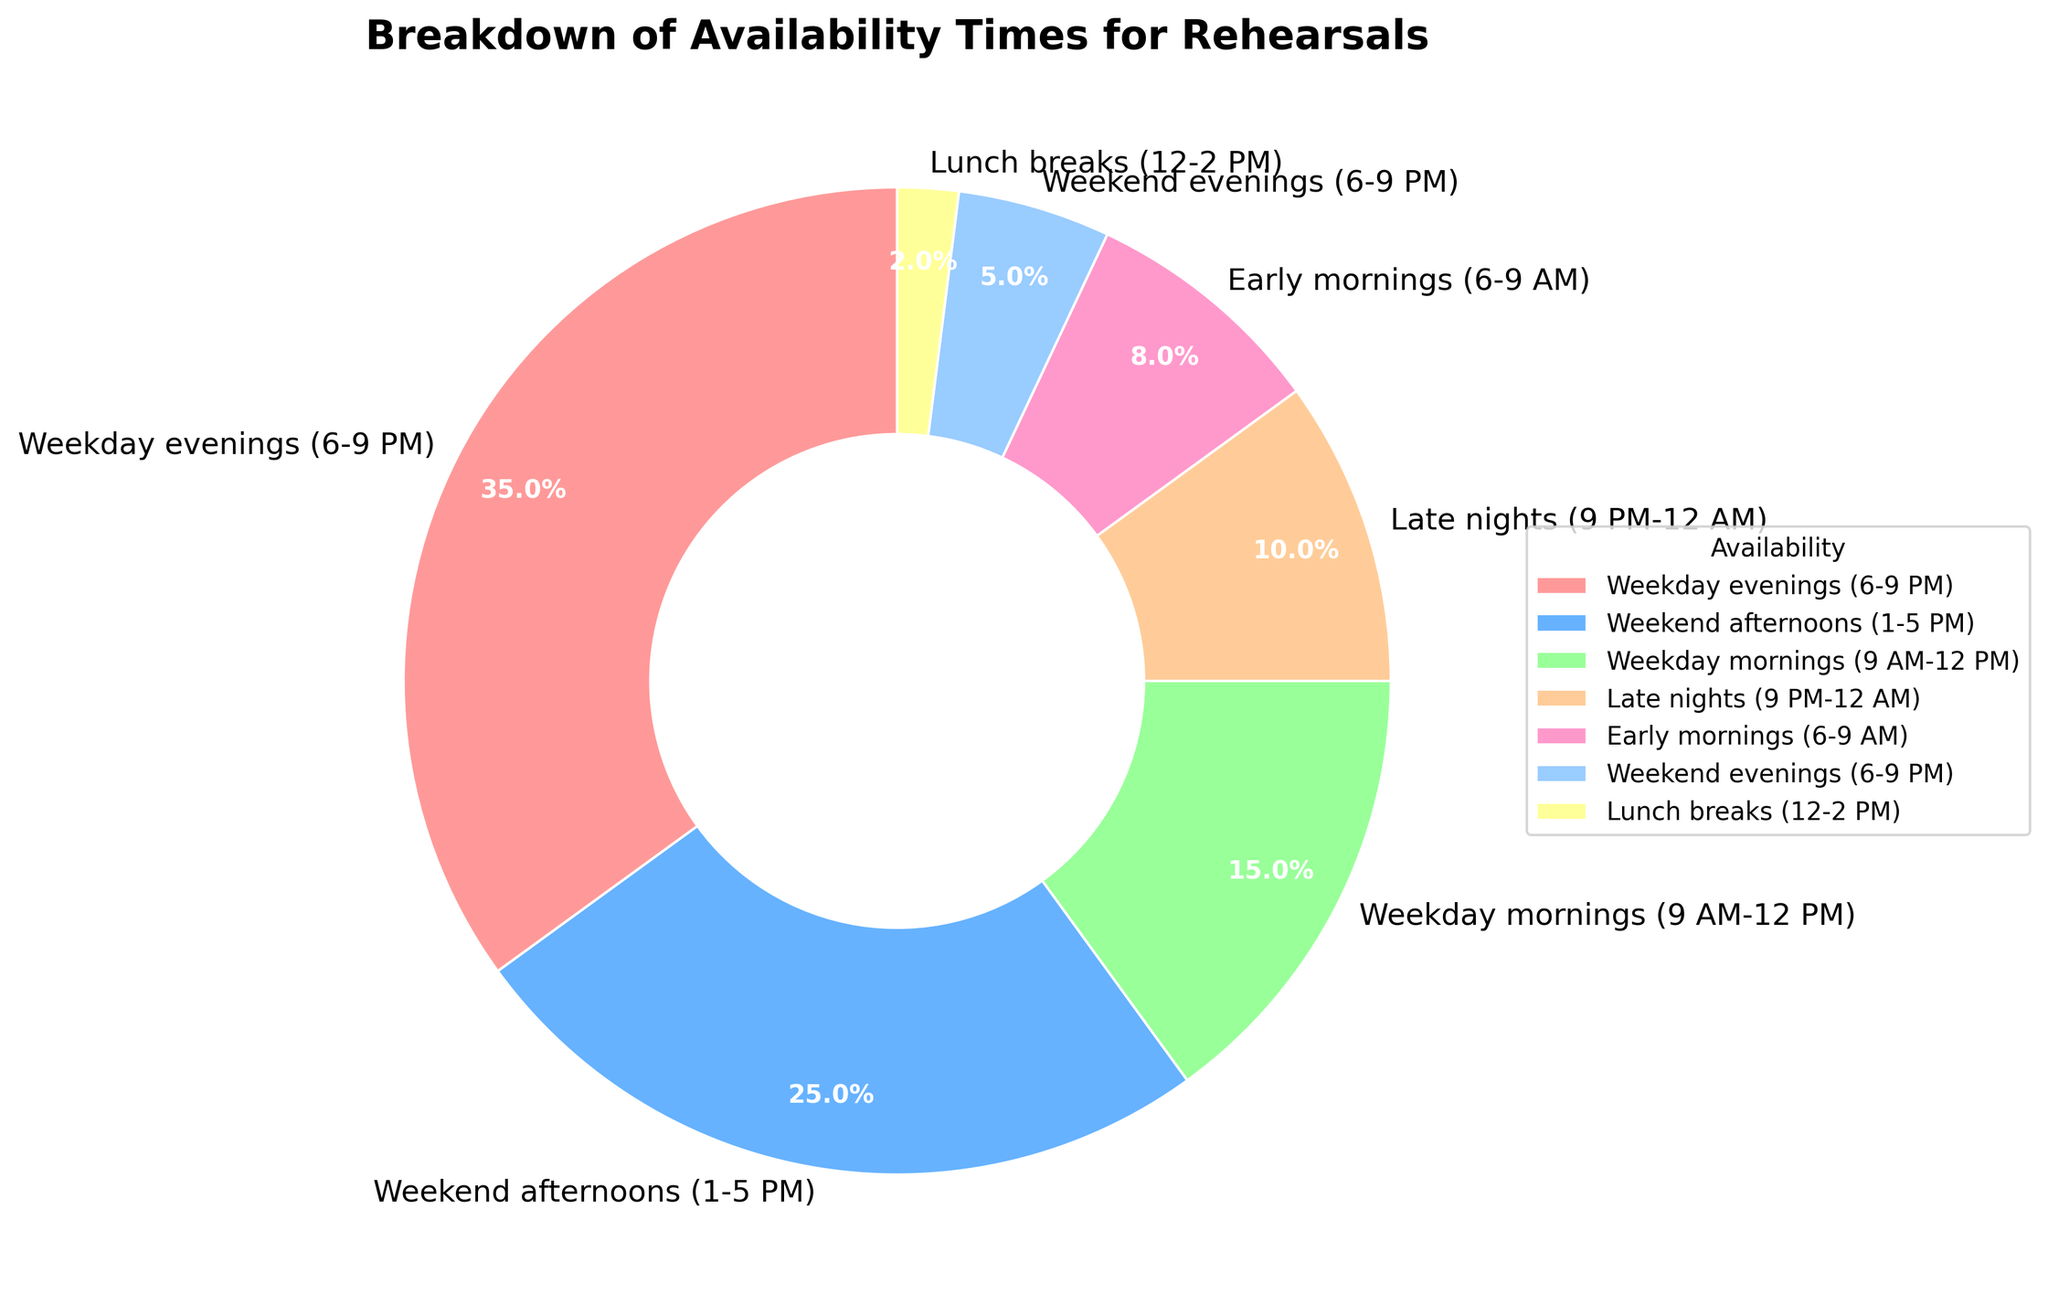Which availability time has the highest percentage? The availability time with the highest percentage is labeled on the pie chart with 35%. According to the chart, Weekday evenings (6-9 PM) has the highest percentage.
Answer: Weekday evenings (6-9 PM) What is the combined percentage of dancers available on weekends (both afternoons and evenings)? The pie chart shows that Weekend afternoons (1-5 PM) account for 25% and Weekend evenings (6-9 PM) account for 5%. Adding these together gives 25% + 5% = 30%.
Answer: 30% Compare the percentage of dancers available in early mornings with those available during late nights. Which is higher and by how much? According to the pie chart, Early mornings (6-9 AM) show 8% availability and Late nights (9 PM-12 AM) show 10% availability. The difference is 10% - 8% = 2%. Late nights have a higher percentage by 2%.
Answer: Late nights by 2% What is the total percentage of dancers who are available on weekdays, excluding afternoons? According to the chart, Weekday evenings (6-9 PM) show 35%, Weekday mornings (9 AM-12 PM) show 15%, and Lunch breaks (12-2 PM) show 2%. Adding these gives 35% + 15% + 2% = 52%.
Answer: 52% Looking at the colors used in the pie chart, which availability time is indicated by the lightest color? The lightest color is typically associated with the label showing the smallest percentage. According to the pie chart, Lunch breaks (12-2 PM) have the smallest percentage at 2% and thus are indicated by the lightest color.
Answer: Lunch breaks (12-2 PM) What is the average percentage of availability for Weekday mornings, Weekday evenings, and Weekend afternoons? Weekday mornings have 15%, Weekday evenings have 35%, and Weekend afternoons have 25%. To find the average: (15% + 35% + 25%) / 3 = 75% / 3 = 25%. The average percentage is 25%.
Answer: 25% Compare the availability of dancers during lunch breaks and early mornings. Which one has a higher percentage, and by how much? Lunch breaks show 2% availability and Early mornings show 8% availability. The difference is 8% - 2% = 6%. Early mornings have a higher percentage by 6%.
Answer: Early mornings by 6% How many availability times have a percentage less than 10%? To determine this, look at the pie chart and count the segments with percentages less than 10%. There are segments for Late nights (10%), Early mornings (8%), Weekend evenings (5%), and Lunch breaks (2%). Out of these, three have less than 10%.
Answer: 3 What percentage of dancers are not available during any part of the weekdays? To find this, sum the percentages for Weekend afternoons and Weekend evenings, which are 25% and 5%, respectively. So, 25% + 5% = 30%.
Answer: 30% 